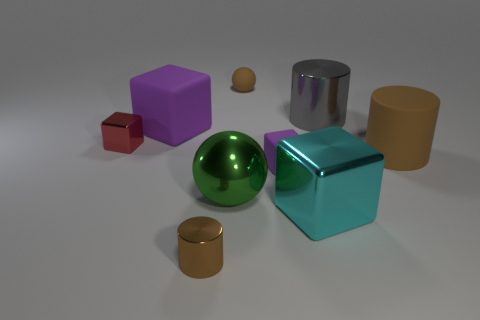Are there fewer large purple matte cubes to the right of the big green thing than large blue cubes?
Make the answer very short. No. What material is the brown thing that is the same size as the brown sphere?
Give a very brief answer. Metal. What size is the brown thing that is both on the left side of the large gray shiny thing and behind the cyan object?
Your response must be concise. Small. What size is the other metal thing that is the same shape as the gray thing?
Give a very brief answer. Small. How many things are large gray rubber spheres or big matte things that are on the right side of the brown metallic cylinder?
Make the answer very short. 1. The cyan shiny thing is what shape?
Give a very brief answer. Cube. There is a brown thing behind the purple thing that is left of the small shiny cylinder; what shape is it?
Your response must be concise. Sphere. There is a tiny cylinder that is the same color as the small ball; what is its material?
Ensure brevity in your answer.  Metal. What is the color of the tiny cylinder that is the same material as the gray object?
Provide a short and direct response. Brown. Does the metallic cylinder that is in front of the big purple cube have the same color as the sphere that is on the right side of the large green thing?
Your answer should be very brief. Yes. 